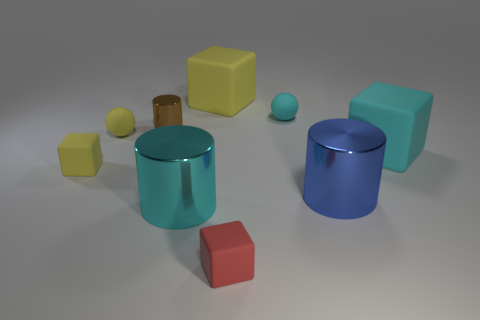Subtract all blue metallic cylinders. How many cylinders are left? 2 Subtract 3 cylinders. How many cylinders are left? 0 Subtract all spheres. How many objects are left? 7 Subtract all cyan cylinders. Subtract all small cyan matte balls. How many objects are left? 7 Add 8 big cyan things. How many big cyan things are left? 10 Add 6 large cyan matte things. How many large cyan matte things exist? 7 Add 1 cyan objects. How many objects exist? 10 Subtract all cyan cylinders. How many cylinders are left? 2 Subtract 0 purple spheres. How many objects are left? 9 Subtract all green balls. Subtract all yellow cubes. How many balls are left? 2 